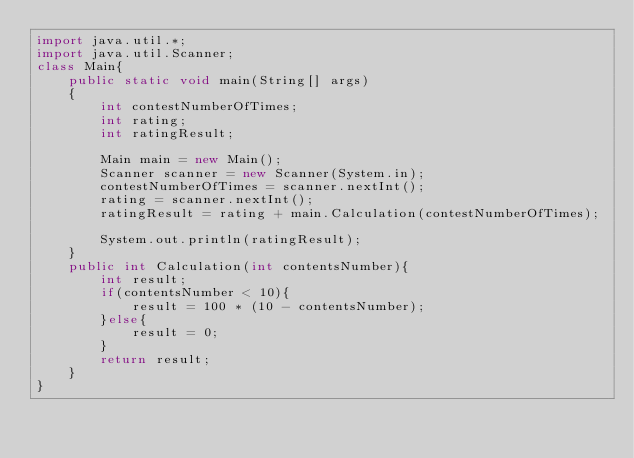Convert code to text. <code><loc_0><loc_0><loc_500><loc_500><_Java_>import java.util.*;
import java.util.Scanner;
class Main{
    public static void main(String[] args)
    {
        int contestNumberOfTimes;
        int rating;
        int ratingResult;
        
        Main main = new Main();
        Scanner scanner = new Scanner(System.in);
        contestNumberOfTimes = scanner.nextInt();
        rating = scanner.nextInt();
        ratingResult = rating + main.Calculation(contestNumberOfTimes);

        System.out.println(ratingResult);
    }
    public int Calculation(int contentsNumber){
        int result;
        if(contentsNumber < 10){
            result = 100 * (10 - contentsNumber);
        }else{
            result = 0;
        }
        return result;
    }
}</code> 